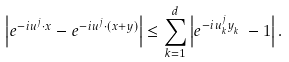Convert formula to latex. <formula><loc_0><loc_0><loc_500><loc_500>\left | e ^ { - i u ^ { j } \cdot x } - e ^ { - i u ^ { j } \cdot ( x + y ) } \right | \leq \sum _ { k = 1 } ^ { d } \left | e ^ { - i u ^ { j } _ { k } y ^ { \ } _ { k } } - 1 \right | .</formula> 